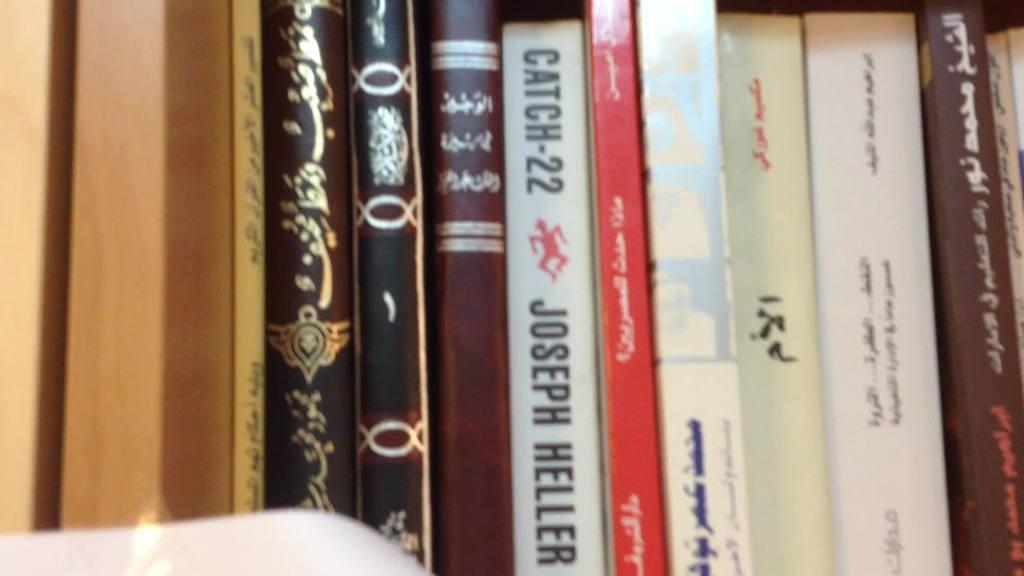<image>
Create a compact narrative representing the image presented. Joseph Heller Catch-22 chapter book with a red man logo. 